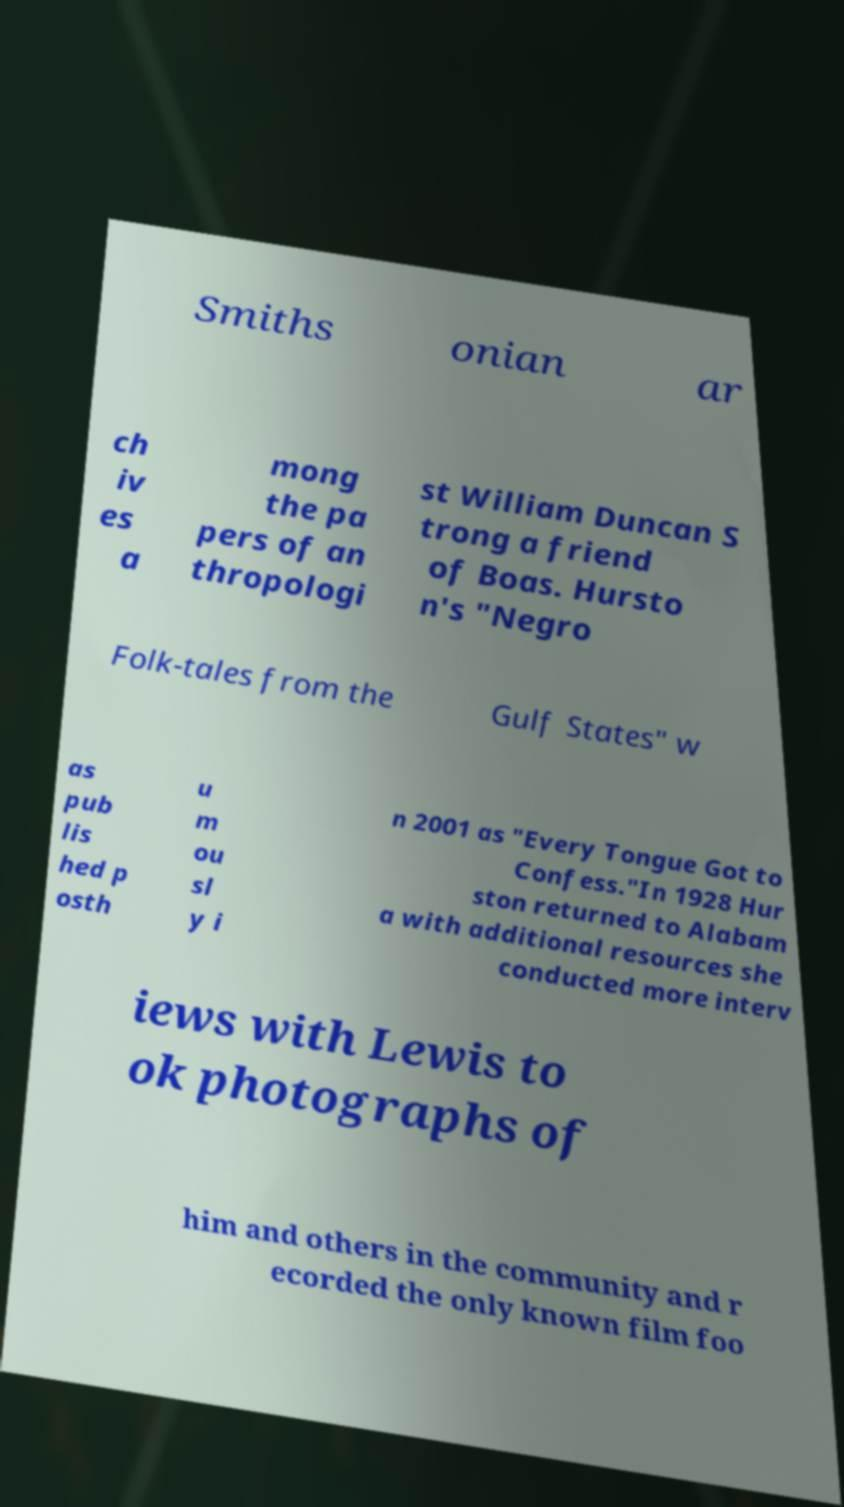For documentation purposes, I need the text within this image transcribed. Could you provide that? Smiths onian ar ch iv es a mong the pa pers of an thropologi st William Duncan S trong a friend of Boas. Hursto n's "Negro Folk-tales from the Gulf States" w as pub lis hed p osth u m ou sl y i n 2001 as "Every Tongue Got to Confess."In 1928 Hur ston returned to Alabam a with additional resources she conducted more interv iews with Lewis to ok photographs of him and others in the community and r ecorded the only known film foo 